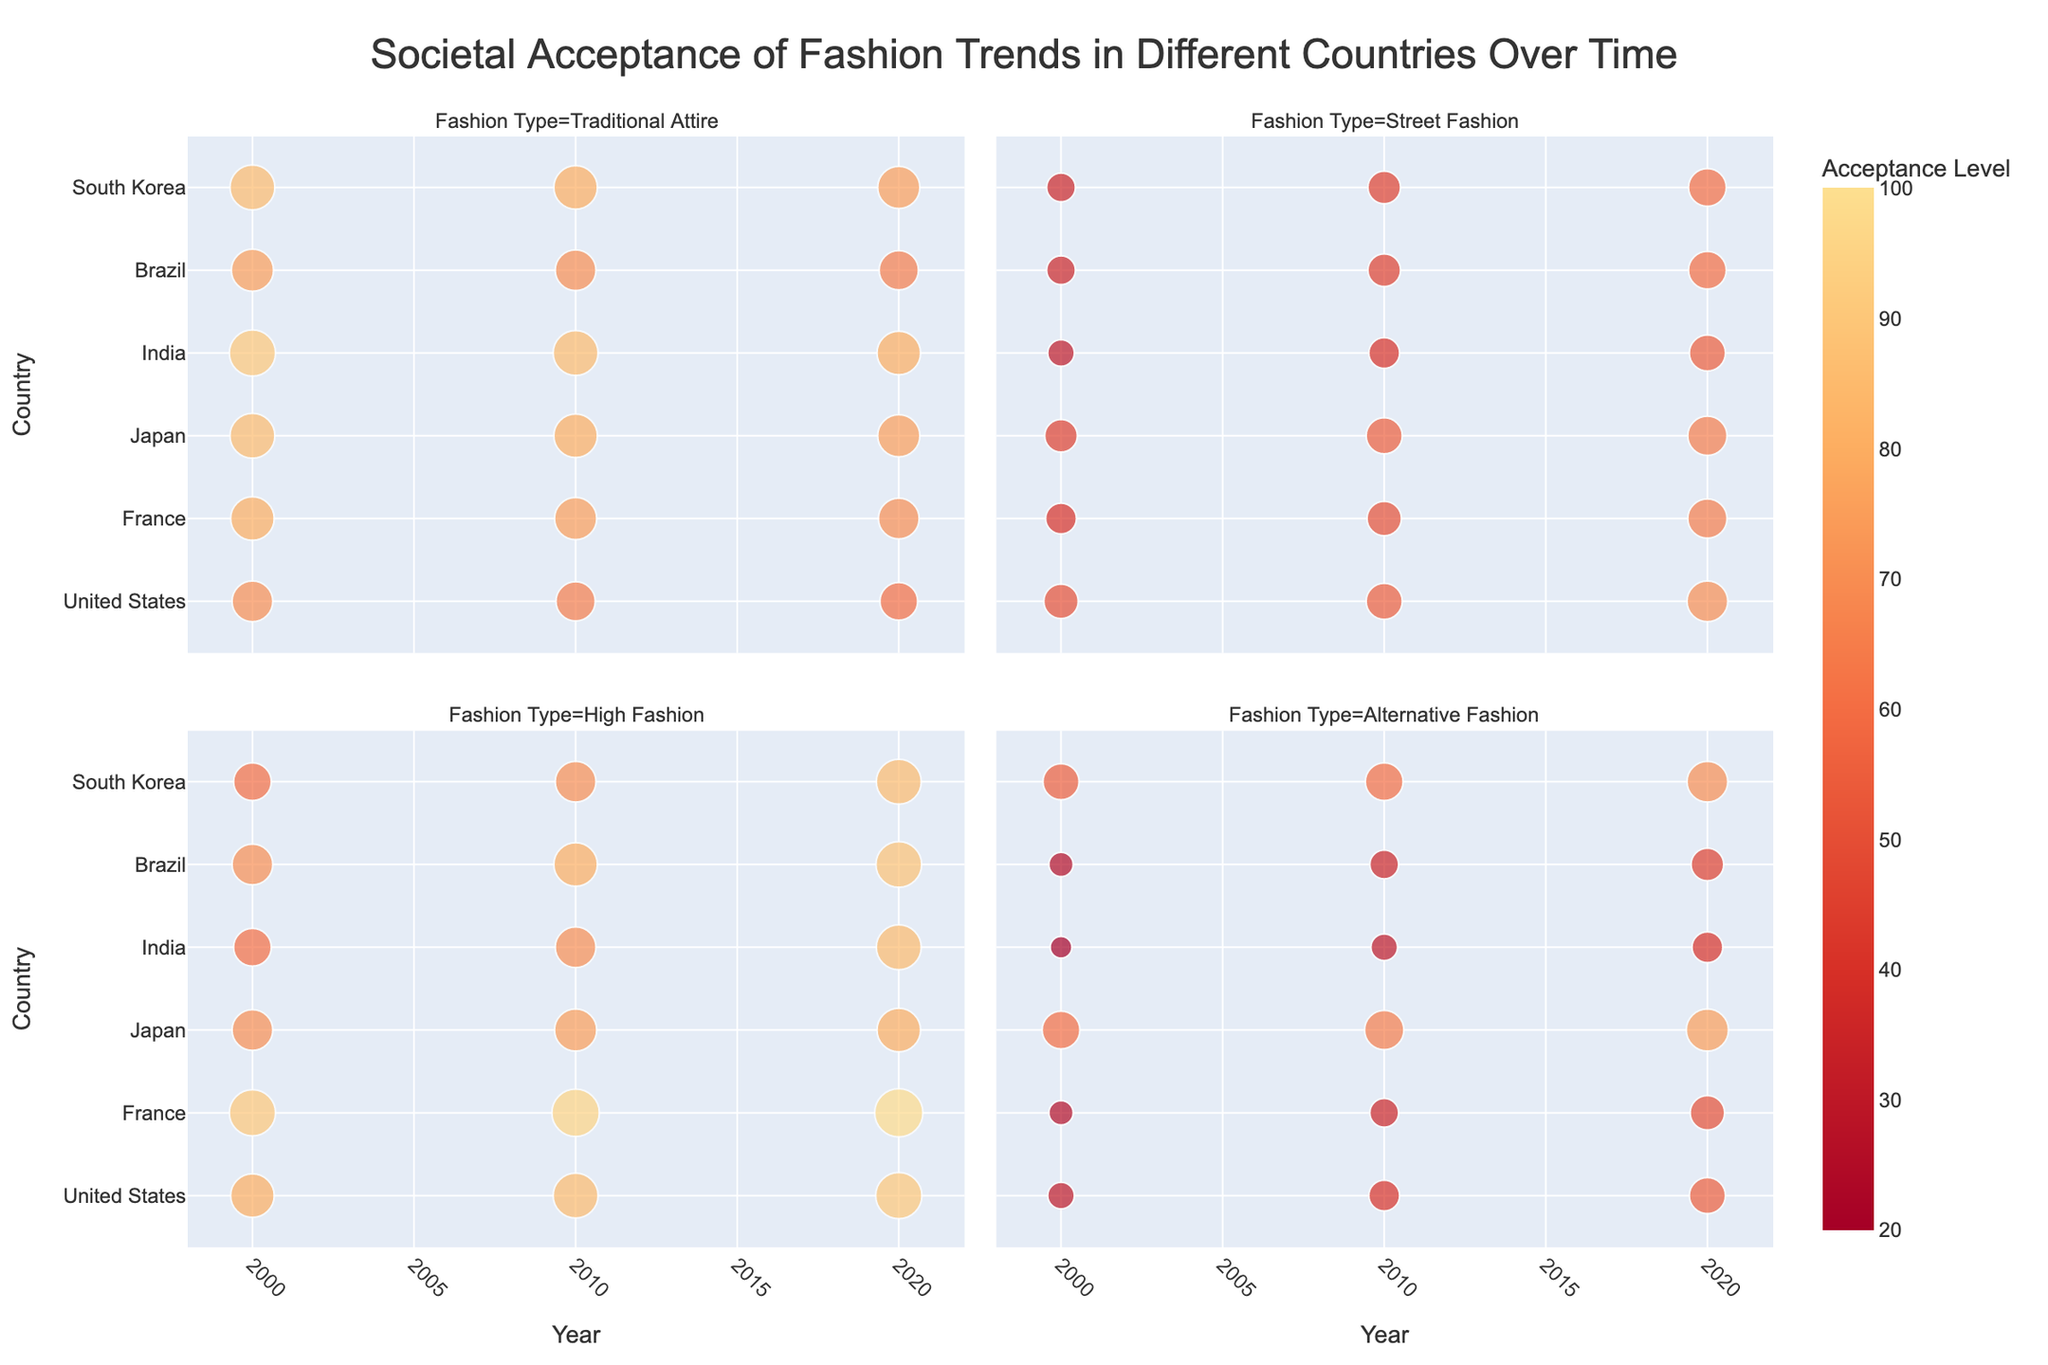What's the title of the figure? The title is typically displayed at the top of the figure, summarizing what the visual represents. By looking at the top center of the figure, we can read the title.
Answer: Societal Acceptance of Fashion Trends in Different Countries Over Time Which fashion trend in France had the highest acceptance level in 2020? To answer this, look at the cells corresponding to France in 2020 and identify the highest value. High Fashion had the highest acceptance level in France in 2020.
Answer: High Fashion Which country had the highest acceptance for Traditional Attire in 2000? To find this, look at the Traditional Attire facet for the year 2000 and compare the acceptance levels of each country. India had the highest acceptance for Traditional Attire in 2000.
Answer: India How did the acceptance of Street Fashion in Brazil change from 2000 to 2020? By examining the Street Fashion facet, compare the acceptance levels of Brazil in 2000, 2010, and 2020. The values show a steady increase from 35 in 2000 to 45 in 2010 and finally to 60 in 2020.
Answer: It increased What is the trend in societal acceptance of Alternative Fashion in Japan from 2000 to 2020? Look at the Alternative Fashion facet for Japan, and observe the values for 2000, 2010, and 2020. The values increased from 60 in 2000 to 65 in 2010 and then to 75 in 2020.
Answer: It increased Compare the acceptance level of High Fashion in the United States and Brazil in 2020. Which is higher and by how much? To answer this, compare the acceptance levels of High Fashion in the United States and Brazil for the year 2020. The United States has an acceptance level of 90, while Brazil has 88, so the difference is 2.
Answer: The US by 2 In which year was the acceptance level for Traditional Attire the highest in South Korea? By looking at the Traditional Attire facet for all the years, locate the highest value across the years for South Korea. The highest value is 85 in the year 2000.
Answer: 2000 What is the average acceptance level of Alternative Fashion across all countries in 2010? To calculate the average, sum the acceptance levels of Alternative Fashion in 2010 for all countries and divide by the number of countries. \( (25 + 35 + 65 + 30 + 35 + 60)/6 \approx 41.67 \)
Answer: ~41.67 Which country showed the greatest increase in acceptance of High Fashion from 2000 to 2020? Examine the High Fashion facet and compare the acceptance changes in each country from 2000 to 2020. Japan had an increase from 70 to 80, an increase of 10.
Answer: Japan 